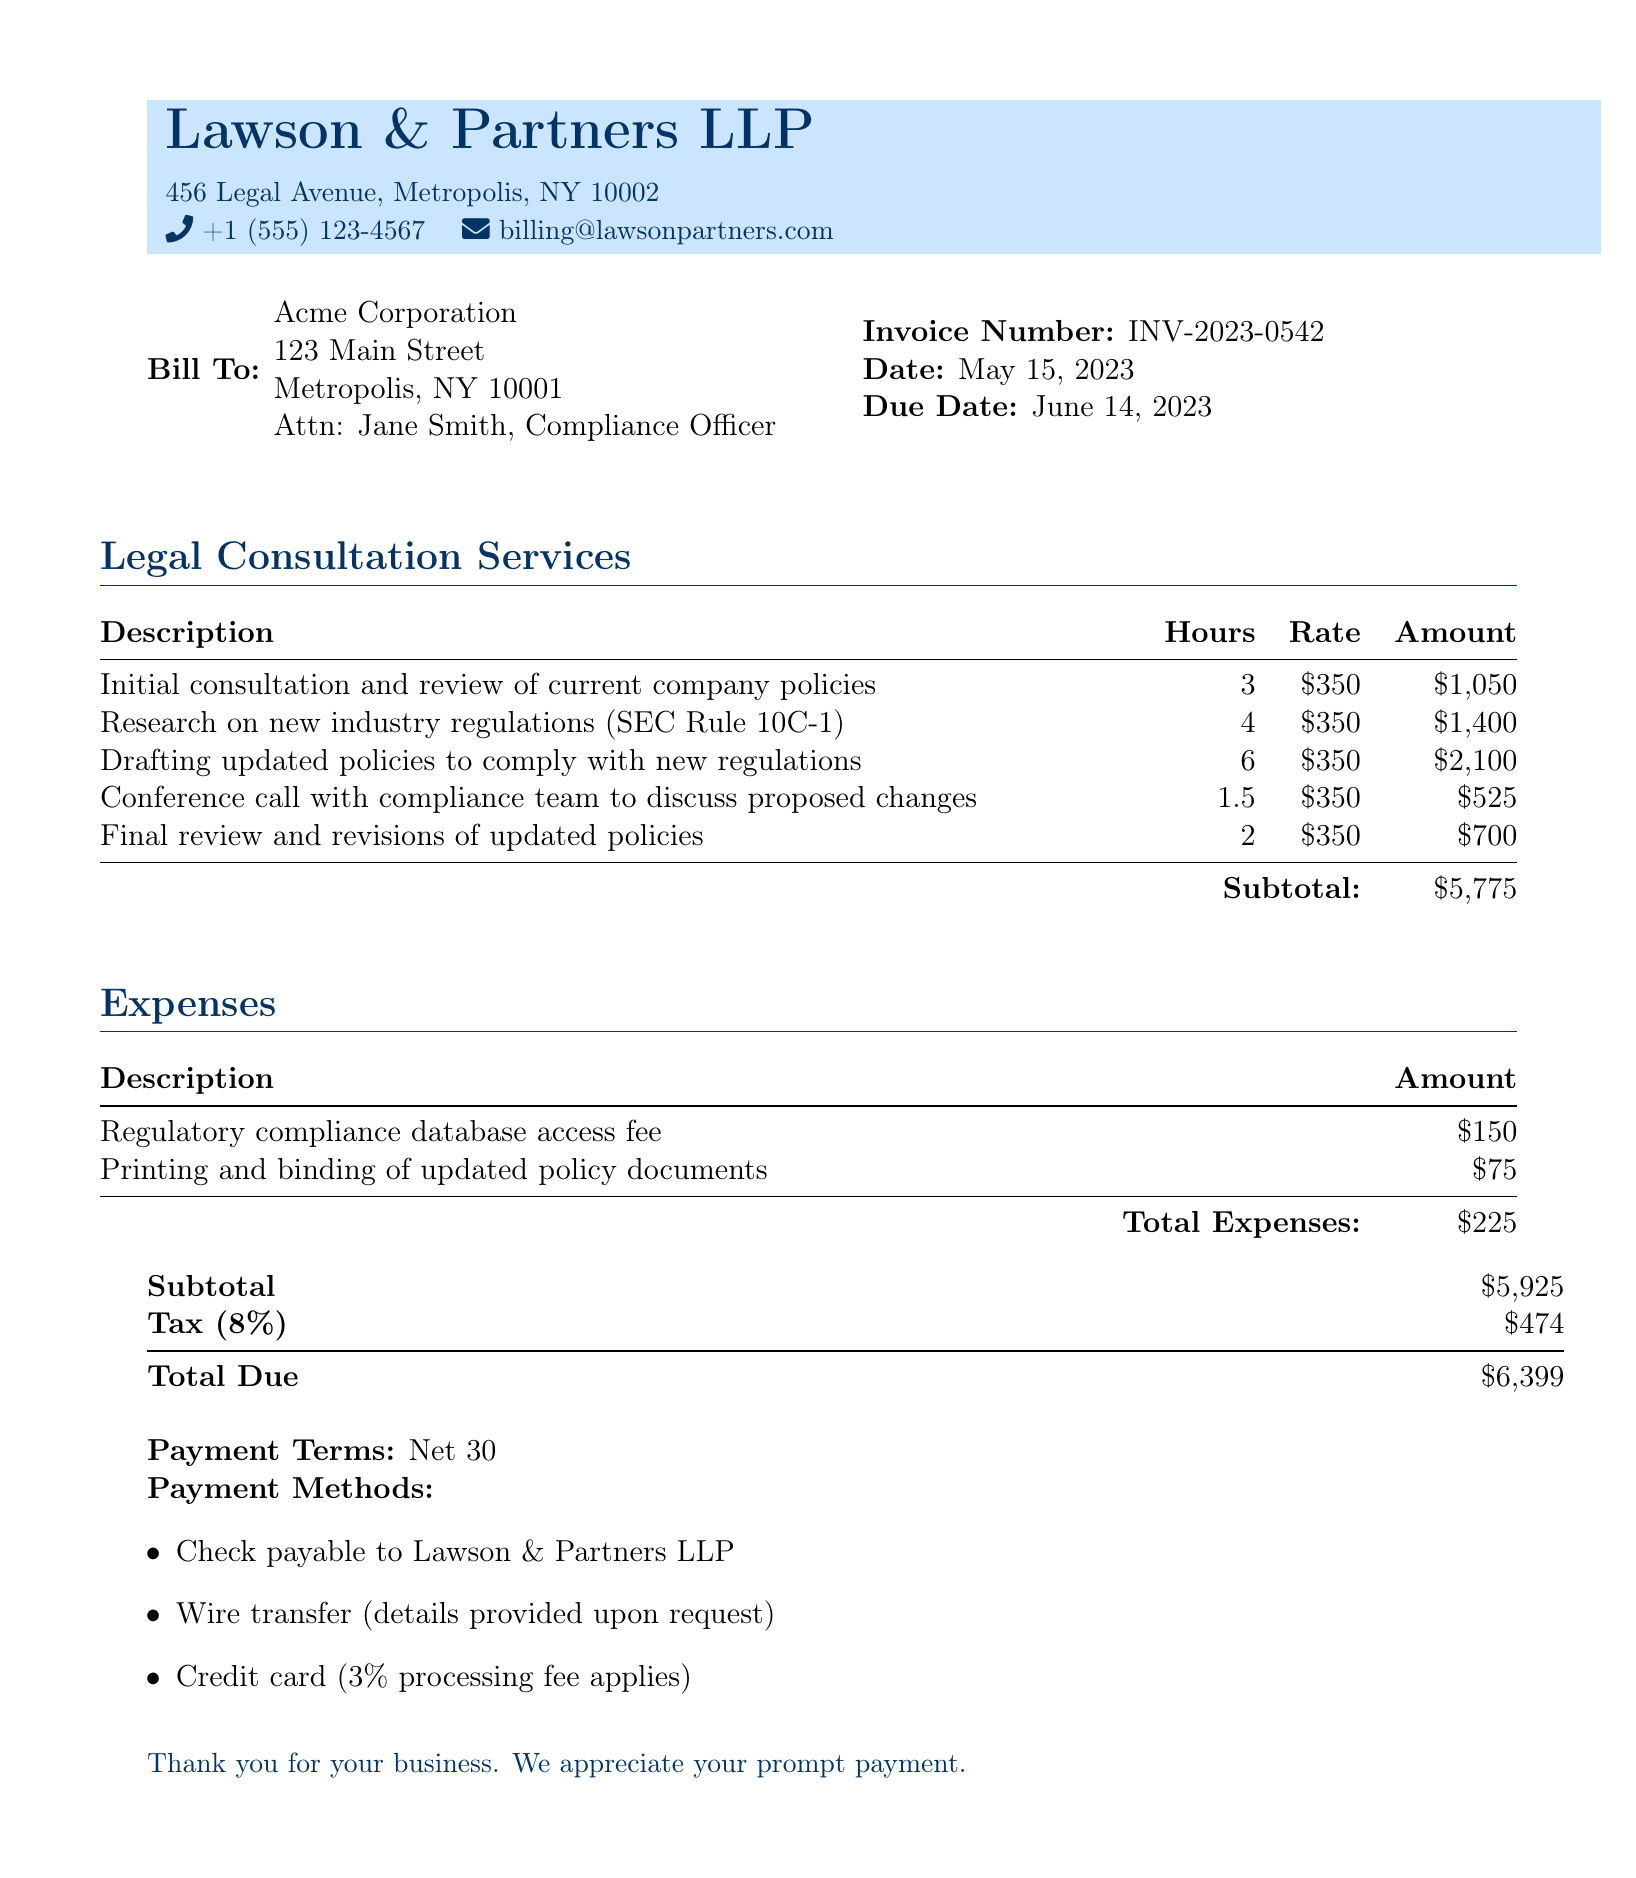What is the invoice number? The invoice number specified in the document is INV-2023-0542.
Answer: INV-2023-0542 What is the total due amount? The total due amount is the final amount calculated at the end of the document, which includes taxes and expenses.
Answer: $6,399 How many hours were spent on drafting updated policies? The number of hours for drafting updated policies is mentioned in the consultation services section, which indicates 6 hours for this task.
Answer: 6 What is the tax rate applied to the subtotal? The tax rate specified in the bill document is 8%.
Answer: 8% Which industry regulation was researched? The document mentions SEC Rule 10C-1 as the regulation researched.
Answer: SEC Rule 10C-1 What type of fee is included in the expenses? The expenses section includes a regulatory compliance database access fee.
Answer: Regulatory compliance database access fee How many hours were billed for the final review? The document states that 2 hours were billed for the final review and revisions of the updated policies.
Answer: 2 Who is the bill addressed to? The bill is addressed to Acme Corporation, with a specific attention line for Jane Smith.
Answer: Acme Corporation What is the due date for the invoice? The due date listed in the document is June 14, 2023.
Answer: June 14, 2023 